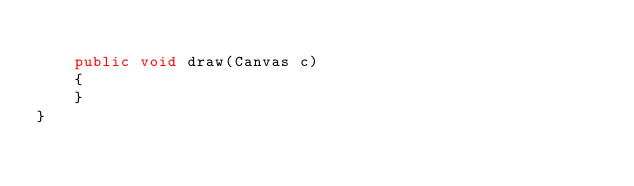<code> <loc_0><loc_0><loc_500><loc_500><_Java_>
	public void draw(Canvas c)
	{
	}
}
</code> 